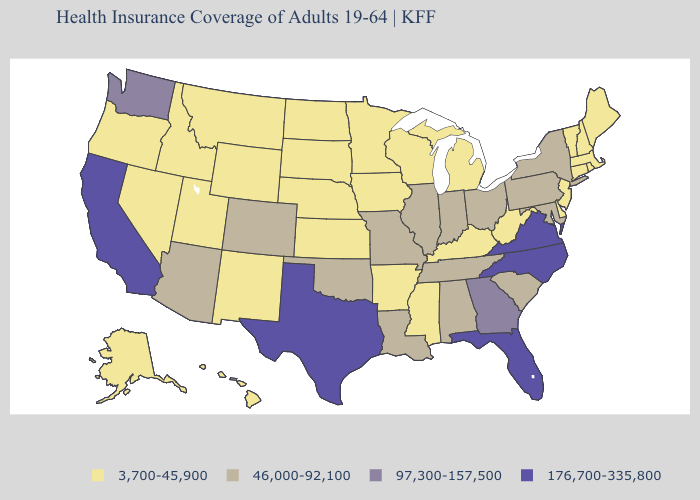Name the states that have a value in the range 176,700-335,800?
Keep it brief. California, Florida, North Carolina, Texas, Virginia. Name the states that have a value in the range 176,700-335,800?
Keep it brief. California, Florida, North Carolina, Texas, Virginia. Does North Dakota have a lower value than Florida?
Write a very short answer. Yes. Among the states that border Delaware , which have the lowest value?
Answer briefly. New Jersey. What is the value of Maryland?
Answer briefly. 46,000-92,100. Does New Mexico have the highest value in the West?
Be succinct. No. Does New York have the lowest value in the Northeast?
Concise answer only. No. What is the lowest value in the USA?
Be succinct. 3,700-45,900. Name the states that have a value in the range 176,700-335,800?
Be succinct. California, Florida, North Carolina, Texas, Virginia. What is the value of Illinois?
Give a very brief answer. 46,000-92,100. What is the value of Michigan?
Keep it brief. 3,700-45,900. What is the lowest value in the USA?
Keep it brief. 3,700-45,900. Does the first symbol in the legend represent the smallest category?
Be succinct. Yes. What is the lowest value in the USA?
Quick response, please. 3,700-45,900. Does the first symbol in the legend represent the smallest category?
Write a very short answer. Yes. 